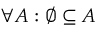Convert formula to latex. <formula><loc_0><loc_0><loc_500><loc_500>\forall A \colon \varnothing \subseteq A</formula> 